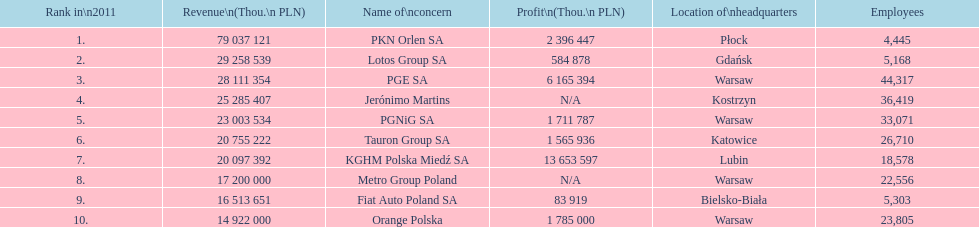Which company had the most employees? PGE SA. 